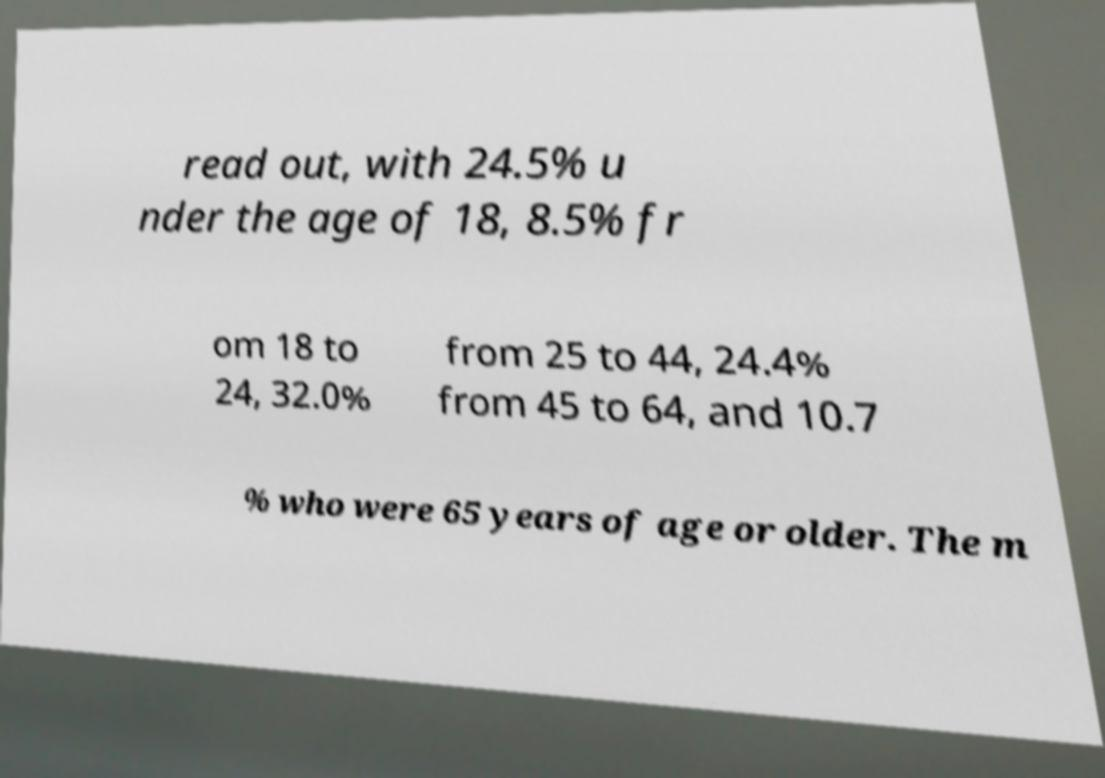Could you extract and type out the text from this image? read out, with 24.5% u nder the age of 18, 8.5% fr om 18 to 24, 32.0% from 25 to 44, 24.4% from 45 to 64, and 10.7 % who were 65 years of age or older. The m 